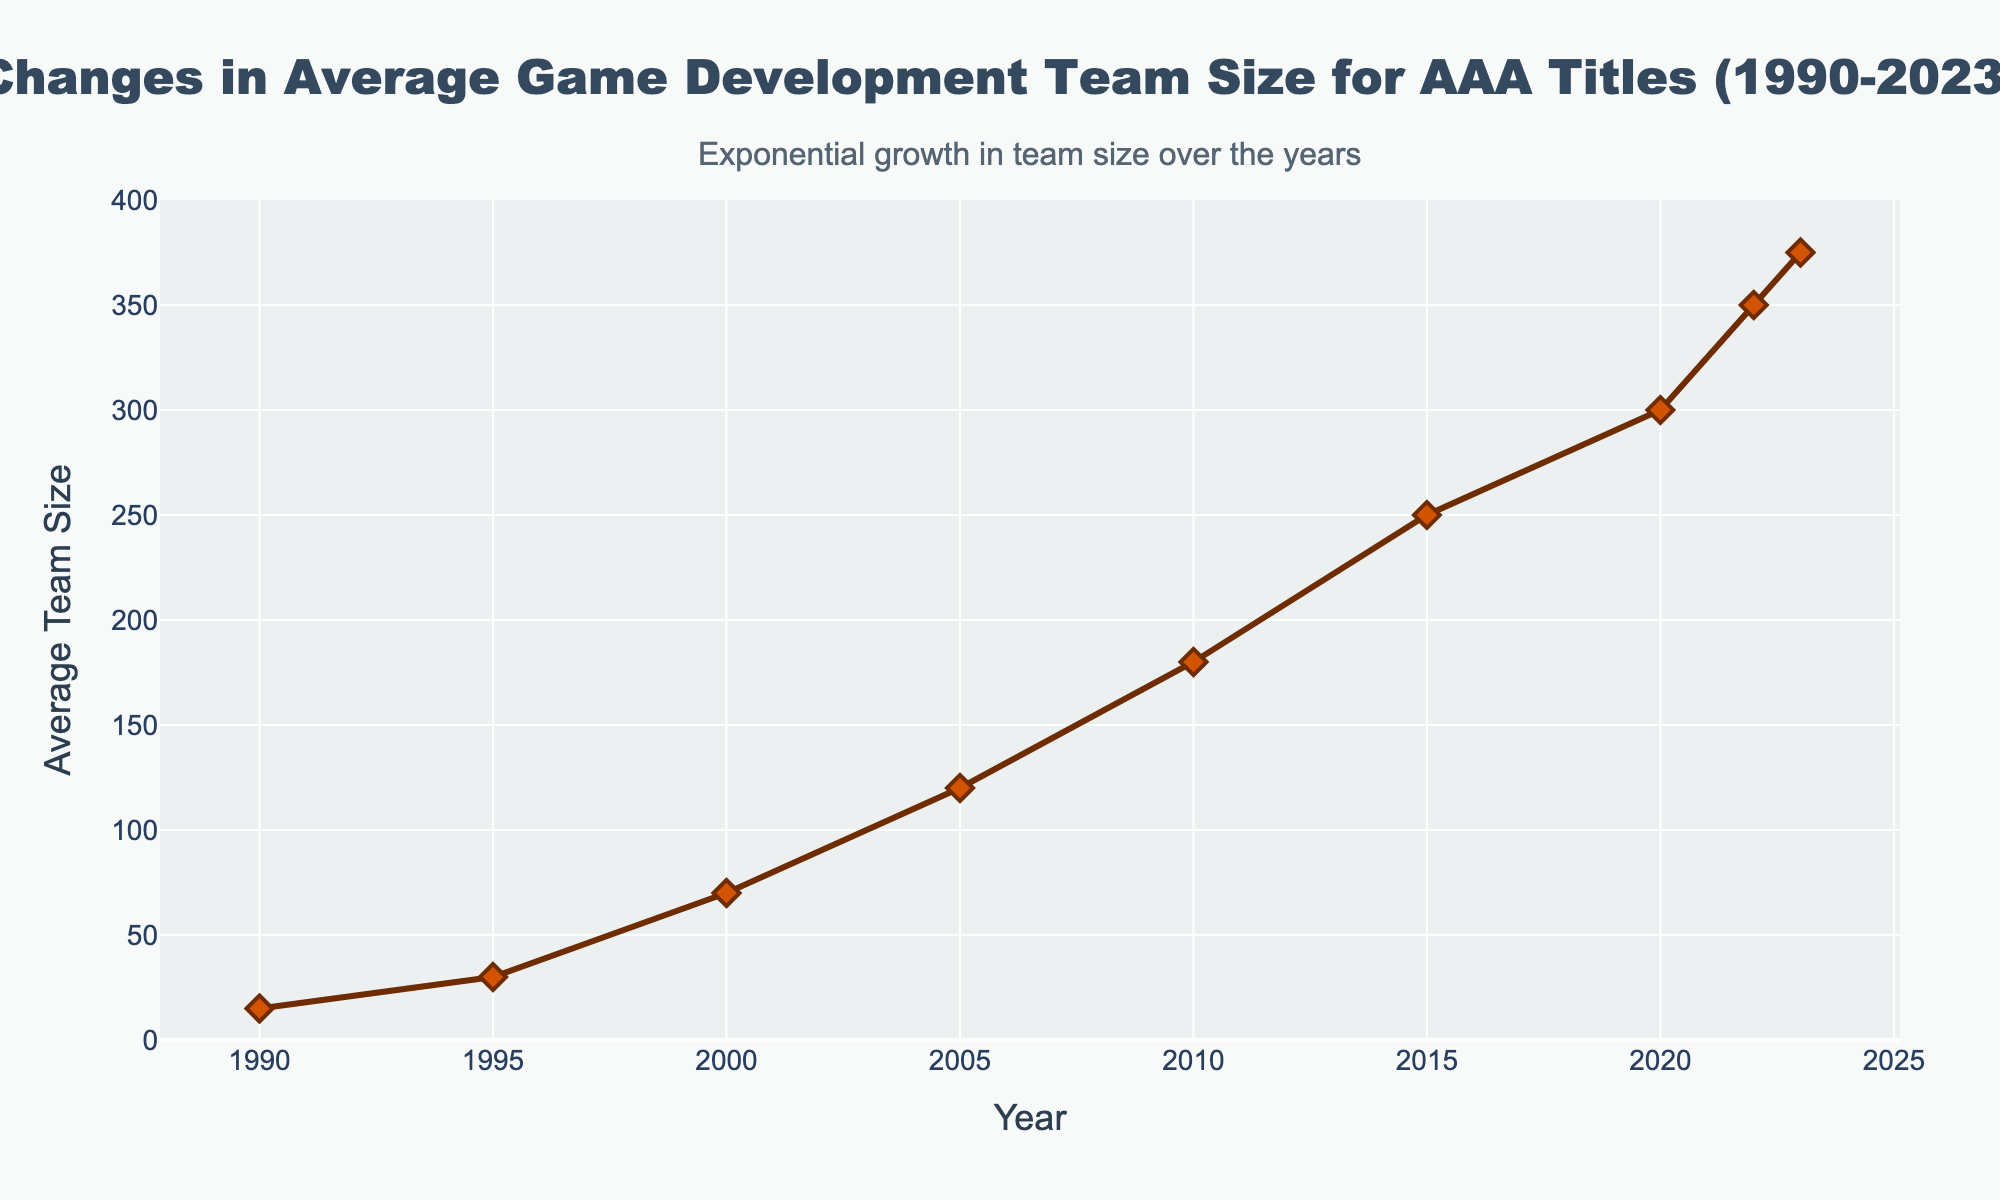What was the average game development team size in the year 2000? Locate the data point for the year 2000 on the x-axis and read its corresponding value on the y-axis, which is indicated by the line.
Answer: 70 By how much did the average team size increase between the years 1990 and 2005? Find the average team sizes for 1990 and 2005 from the plot (15 and 120, respectively), then subtract the size in 1990 from the size in 2005 (120 - 15).
Answer: 105 Which year saw a larger team size: 2010 or 2020? Compare the y-values corresponding to the years 2010 and 2020 on the plot. The value for 2020 is higher than that for 2010.
Answer: 2020 What is the difference in average team size between 2015 and 2023? Locate the average team sizes for 2015 and 2023 on the chart (250 and 375, respectively), then subtract the size in 2015 from the size in 2023 (375 - 250).
Answer: 125 How many times larger was the average team size in 2023 compared to 1990? Find the average team sizes for 1990 and 2023 (15 and 375), then divide the team size in 2023 by the team size in 1990 (375 / 15).
Answer: 25 What general trend is noticeable in the average team size over the years? Examine the direction and slope of the line from left to right, observing that it steadily rises, indicating an increase in team size over the years.
Answer: Increasing What was the approximate average game development team size around the year 2012? Estimate the y-value around the year 2012 by observing the closest data points in 2010 (180) and 2015 (250), implying an approximate value.
Answer: Approximately 200 In which 5-year period did the average team size see the steepest increase? Compare the slope of line segments over each 5-year period. The steepest increase is from 2015 to 2020 (250 to 300).
Answer: 2015-2020 Describe the shape of the data trend from 1990 to 2023. Observe the overall form of the plotted line, noting that it shows an exponential growth pattern as it becomes steeper over time.
Answer: Exponential growth By what percentage did the average team size increase from 2010 to 2023? Calculate the percentage increase: first, find the difference in team sizes (375 - 180 = 195), then divide by the initial value (180) and multiply by 100 (195 / 180 * 100).
Answer: 108.33% 